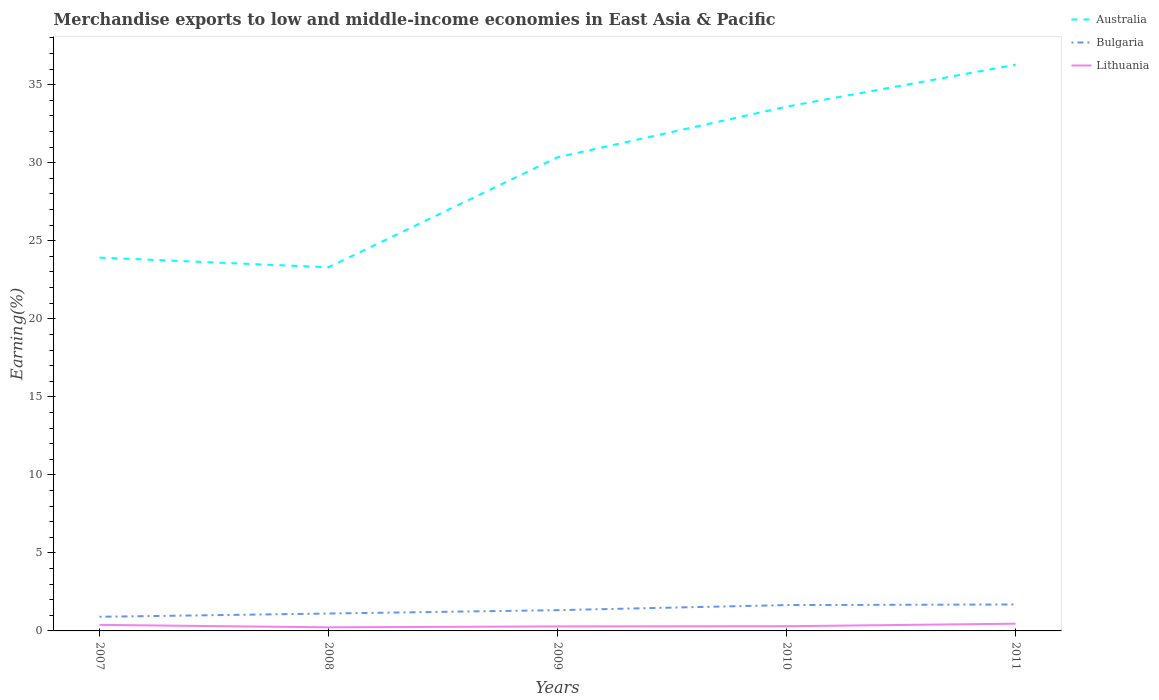Across all years, what is the maximum percentage of amount earned from merchandise exports in Australia?
Give a very brief answer. 23.3. What is the total percentage of amount earned from merchandise exports in Lithuania in the graph?
Your answer should be compact. -0.23. What is the difference between the highest and the second highest percentage of amount earned from merchandise exports in Bulgaria?
Keep it short and to the point. 0.79. How many lines are there?
Offer a very short reply. 3. What is the difference between two consecutive major ticks on the Y-axis?
Keep it short and to the point. 5. Are the values on the major ticks of Y-axis written in scientific E-notation?
Keep it short and to the point. No. Where does the legend appear in the graph?
Your answer should be very brief. Top right. How many legend labels are there?
Your answer should be very brief. 3. How are the legend labels stacked?
Your answer should be compact. Vertical. What is the title of the graph?
Your response must be concise. Merchandise exports to low and middle-income economies in East Asia & Pacific. What is the label or title of the X-axis?
Your response must be concise. Years. What is the label or title of the Y-axis?
Provide a short and direct response. Earning(%). What is the Earning(%) in Australia in 2007?
Offer a very short reply. 23.92. What is the Earning(%) of Bulgaria in 2007?
Your response must be concise. 0.91. What is the Earning(%) in Lithuania in 2007?
Give a very brief answer. 0.39. What is the Earning(%) of Australia in 2008?
Offer a terse response. 23.3. What is the Earning(%) of Bulgaria in 2008?
Your answer should be compact. 1.11. What is the Earning(%) of Lithuania in 2008?
Your answer should be compact. 0.23. What is the Earning(%) of Australia in 2009?
Your response must be concise. 30.35. What is the Earning(%) of Bulgaria in 2009?
Provide a short and direct response. 1.33. What is the Earning(%) in Lithuania in 2009?
Your answer should be very brief. 0.29. What is the Earning(%) in Australia in 2010?
Ensure brevity in your answer.  33.6. What is the Earning(%) of Bulgaria in 2010?
Make the answer very short. 1.66. What is the Earning(%) of Lithuania in 2010?
Provide a short and direct response. 0.3. What is the Earning(%) in Australia in 2011?
Your answer should be compact. 36.28. What is the Earning(%) in Bulgaria in 2011?
Your answer should be very brief. 1.69. What is the Earning(%) of Lithuania in 2011?
Give a very brief answer. 0.46. Across all years, what is the maximum Earning(%) in Australia?
Offer a terse response. 36.28. Across all years, what is the maximum Earning(%) of Bulgaria?
Make the answer very short. 1.69. Across all years, what is the maximum Earning(%) in Lithuania?
Your answer should be very brief. 0.46. Across all years, what is the minimum Earning(%) in Australia?
Provide a succinct answer. 23.3. Across all years, what is the minimum Earning(%) in Bulgaria?
Provide a succinct answer. 0.91. Across all years, what is the minimum Earning(%) in Lithuania?
Make the answer very short. 0.23. What is the total Earning(%) of Australia in the graph?
Your answer should be compact. 147.46. What is the total Earning(%) in Bulgaria in the graph?
Offer a very short reply. 6.7. What is the total Earning(%) in Lithuania in the graph?
Provide a short and direct response. 1.67. What is the difference between the Earning(%) in Australia in 2007 and that in 2008?
Your response must be concise. 0.62. What is the difference between the Earning(%) in Bulgaria in 2007 and that in 2008?
Give a very brief answer. -0.21. What is the difference between the Earning(%) in Lithuania in 2007 and that in 2008?
Keep it short and to the point. 0.16. What is the difference between the Earning(%) in Australia in 2007 and that in 2009?
Provide a succinct answer. -6.43. What is the difference between the Earning(%) in Bulgaria in 2007 and that in 2009?
Give a very brief answer. -0.42. What is the difference between the Earning(%) in Lithuania in 2007 and that in 2009?
Your answer should be compact. 0.1. What is the difference between the Earning(%) of Australia in 2007 and that in 2010?
Your answer should be compact. -9.68. What is the difference between the Earning(%) in Bulgaria in 2007 and that in 2010?
Offer a very short reply. -0.75. What is the difference between the Earning(%) in Lithuania in 2007 and that in 2010?
Give a very brief answer. 0.09. What is the difference between the Earning(%) in Australia in 2007 and that in 2011?
Offer a terse response. -12.36. What is the difference between the Earning(%) in Bulgaria in 2007 and that in 2011?
Your answer should be very brief. -0.79. What is the difference between the Earning(%) of Lithuania in 2007 and that in 2011?
Provide a succinct answer. -0.08. What is the difference between the Earning(%) of Australia in 2008 and that in 2009?
Ensure brevity in your answer.  -7.05. What is the difference between the Earning(%) in Bulgaria in 2008 and that in 2009?
Your answer should be very brief. -0.22. What is the difference between the Earning(%) of Lithuania in 2008 and that in 2009?
Your response must be concise. -0.06. What is the difference between the Earning(%) in Australia in 2008 and that in 2010?
Make the answer very short. -10.29. What is the difference between the Earning(%) in Bulgaria in 2008 and that in 2010?
Your response must be concise. -0.54. What is the difference between the Earning(%) in Lithuania in 2008 and that in 2010?
Your answer should be compact. -0.07. What is the difference between the Earning(%) of Australia in 2008 and that in 2011?
Provide a short and direct response. -12.98. What is the difference between the Earning(%) in Bulgaria in 2008 and that in 2011?
Provide a short and direct response. -0.58. What is the difference between the Earning(%) of Lithuania in 2008 and that in 2011?
Your answer should be compact. -0.23. What is the difference between the Earning(%) in Australia in 2009 and that in 2010?
Your answer should be very brief. -3.25. What is the difference between the Earning(%) of Bulgaria in 2009 and that in 2010?
Ensure brevity in your answer.  -0.33. What is the difference between the Earning(%) in Lithuania in 2009 and that in 2010?
Your answer should be compact. -0.01. What is the difference between the Earning(%) in Australia in 2009 and that in 2011?
Keep it short and to the point. -5.93. What is the difference between the Earning(%) in Bulgaria in 2009 and that in 2011?
Ensure brevity in your answer.  -0.36. What is the difference between the Earning(%) of Lithuania in 2009 and that in 2011?
Your answer should be compact. -0.17. What is the difference between the Earning(%) of Australia in 2010 and that in 2011?
Keep it short and to the point. -2.69. What is the difference between the Earning(%) in Bulgaria in 2010 and that in 2011?
Offer a terse response. -0.04. What is the difference between the Earning(%) of Lithuania in 2010 and that in 2011?
Your answer should be compact. -0.16. What is the difference between the Earning(%) in Australia in 2007 and the Earning(%) in Bulgaria in 2008?
Offer a very short reply. 22.81. What is the difference between the Earning(%) in Australia in 2007 and the Earning(%) in Lithuania in 2008?
Provide a short and direct response. 23.69. What is the difference between the Earning(%) of Bulgaria in 2007 and the Earning(%) of Lithuania in 2008?
Keep it short and to the point. 0.67. What is the difference between the Earning(%) of Australia in 2007 and the Earning(%) of Bulgaria in 2009?
Make the answer very short. 22.59. What is the difference between the Earning(%) in Australia in 2007 and the Earning(%) in Lithuania in 2009?
Your answer should be compact. 23.63. What is the difference between the Earning(%) of Bulgaria in 2007 and the Earning(%) of Lithuania in 2009?
Ensure brevity in your answer.  0.62. What is the difference between the Earning(%) in Australia in 2007 and the Earning(%) in Bulgaria in 2010?
Provide a short and direct response. 22.26. What is the difference between the Earning(%) in Australia in 2007 and the Earning(%) in Lithuania in 2010?
Your response must be concise. 23.62. What is the difference between the Earning(%) in Bulgaria in 2007 and the Earning(%) in Lithuania in 2010?
Provide a succinct answer. 0.6. What is the difference between the Earning(%) in Australia in 2007 and the Earning(%) in Bulgaria in 2011?
Provide a succinct answer. 22.23. What is the difference between the Earning(%) of Australia in 2007 and the Earning(%) of Lithuania in 2011?
Make the answer very short. 23.46. What is the difference between the Earning(%) of Bulgaria in 2007 and the Earning(%) of Lithuania in 2011?
Offer a terse response. 0.44. What is the difference between the Earning(%) in Australia in 2008 and the Earning(%) in Bulgaria in 2009?
Your response must be concise. 21.97. What is the difference between the Earning(%) in Australia in 2008 and the Earning(%) in Lithuania in 2009?
Keep it short and to the point. 23.01. What is the difference between the Earning(%) of Bulgaria in 2008 and the Earning(%) of Lithuania in 2009?
Offer a terse response. 0.83. What is the difference between the Earning(%) of Australia in 2008 and the Earning(%) of Bulgaria in 2010?
Your response must be concise. 21.65. What is the difference between the Earning(%) in Australia in 2008 and the Earning(%) in Lithuania in 2010?
Give a very brief answer. 23. What is the difference between the Earning(%) of Bulgaria in 2008 and the Earning(%) of Lithuania in 2010?
Make the answer very short. 0.81. What is the difference between the Earning(%) of Australia in 2008 and the Earning(%) of Bulgaria in 2011?
Make the answer very short. 21.61. What is the difference between the Earning(%) of Australia in 2008 and the Earning(%) of Lithuania in 2011?
Offer a terse response. 22.84. What is the difference between the Earning(%) of Bulgaria in 2008 and the Earning(%) of Lithuania in 2011?
Keep it short and to the point. 0.65. What is the difference between the Earning(%) of Australia in 2009 and the Earning(%) of Bulgaria in 2010?
Your answer should be very brief. 28.69. What is the difference between the Earning(%) of Australia in 2009 and the Earning(%) of Lithuania in 2010?
Give a very brief answer. 30.05. What is the difference between the Earning(%) in Bulgaria in 2009 and the Earning(%) in Lithuania in 2010?
Offer a very short reply. 1.03. What is the difference between the Earning(%) in Australia in 2009 and the Earning(%) in Bulgaria in 2011?
Provide a short and direct response. 28.66. What is the difference between the Earning(%) in Australia in 2009 and the Earning(%) in Lithuania in 2011?
Provide a succinct answer. 29.89. What is the difference between the Earning(%) in Bulgaria in 2009 and the Earning(%) in Lithuania in 2011?
Keep it short and to the point. 0.87. What is the difference between the Earning(%) in Australia in 2010 and the Earning(%) in Bulgaria in 2011?
Offer a very short reply. 31.9. What is the difference between the Earning(%) in Australia in 2010 and the Earning(%) in Lithuania in 2011?
Give a very brief answer. 33.13. What is the difference between the Earning(%) of Bulgaria in 2010 and the Earning(%) of Lithuania in 2011?
Your answer should be compact. 1.19. What is the average Earning(%) in Australia per year?
Keep it short and to the point. 29.49. What is the average Earning(%) of Bulgaria per year?
Offer a terse response. 1.34. What is the average Earning(%) of Lithuania per year?
Your answer should be very brief. 0.33. In the year 2007, what is the difference between the Earning(%) of Australia and Earning(%) of Bulgaria?
Ensure brevity in your answer.  23.02. In the year 2007, what is the difference between the Earning(%) of Australia and Earning(%) of Lithuania?
Provide a succinct answer. 23.53. In the year 2007, what is the difference between the Earning(%) in Bulgaria and Earning(%) in Lithuania?
Offer a very short reply. 0.52. In the year 2008, what is the difference between the Earning(%) of Australia and Earning(%) of Bulgaria?
Provide a succinct answer. 22.19. In the year 2008, what is the difference between the Earning(%) in Australia and Earning(%) in Lithuania?
Provide a succinct answer. 23.07. In the year 2008, what is the difference between the Earning(%) of Bulgaria and Earning(%) of Lithuania?
Offer a terse response. 0.88. In the year 2009, what is the difference between the Earning(%) of Australia and Earning(%) of Bulgaria?
Make the answer very short. 29.02. In the year 2009, what is the difference between the Earning(%) in Australia and Earning(%) in Lithuania?
Provide a short and direct response. 30.06. In the year 2009, what is the difference between the Earning(%) in Bulgaria and Earning(%) in Lithuania?
Offer a terse response. 1.04. In the year 2010, what is the difference between the Earning(%) in Australia and Earning(%) in Bulgaria?
Provide a succinct answer. 31.94. In the year 2010, what is the difference between the Earning(%) of Australia and Earning(%) of Lithuania?
Your answer should be very brief. 33.3. In the year 2010, what is the difference between the Earning(%) of Bulgaria and Earning(%) of Lithuania?
Your answer should be compact. 1.36. In the year 2011, what is the difference between the Earning(%) in Australia and Earning(%) in Bulgaria?
Your answer should be compact. 34.59. In the year 2011, what is the difference between the Earning(%) in Australia and Earning(%) in Lithuania?
Give a very brief answer. 35.82. In the year 2011, what is the difference between the Earning(%) in Bulgaria and Earning(%) in Lithuania?
Offer a very short reply. 1.23. What is the ratio of the Earning(%) in Australia in 2007 to that in 2008?
Offer a terse response. 1.03. What is the ratio of the Earning(%) in Bulgaria in 2007 to that in 2008?
Keep it short and to the point. 0.81. What is the ratio of the Earning(%) of Lithuania in 2007 to that in 2008?
Your response must be concise. 1.68. What is the ratio of the Earning(%) in Australia in 2007 to that in 2009?
Offer a very short reply. 0.79. What is the ratio of the Earning(%) of Bulgaria in 2007 to that in 2009?
Give a very brief answer. 0.68. What is the ratio of the Earning(%) in Lithuania in 2007 to that in 2009?
Your response must be concise. 1.34. What is the ratio of the Earning(%) in Australia in 2007 to that in 2010?
Give a very brief answer. 0.71. What is the ratio of the Earning(%) of Bulgaria in 2007 to that in 2010?
Give a very brief answer. 0.55. What is the ratio of the Earning(%) of Lithuania in 2007 to that in 2010?
Offer a very short reply. 1.28. What is the ratio of the Earning(%) of Australia in 2007 to that in 2011?
Your response must be concise. 0.66. What is the ratio of the Earning(%) of Bulgaria in 2007 to that in 2011?
Your answer should be very brief. 0.53. What is the ratio of the Earning(%) of Lithuania in 2007 to that in 2011?
Your response must be concise. 0.84. What is the ratio of the Earning(%) of Australia in 2008 to that in 2009?
Provide a succinct answer. 0.77. What is the ratio of the Earning(%) of Bulgaria in 2008 to that in 2009?
Make the answer very short. 0.84. What is the ratio of the Earning(%) of Lithuania in 2008 to that in 2009?
Provide a short and direct response. 0.8. What is the ratio of the Earning(%) in Australia in 2008 to that in 2010?
Ensure brevity in your answer.  0.69. What is the ratio of the Earning(%) of Bulgaria in 2008 to that in 2010?
Your answer should be compact. 0.67. What is the ratio of the Earning(%) of Lithuania in 2008 to that in 2010?
Your response must be concise. 0.77. What is the ratio of the Earning(%) in Australia in 2008 to that in 2011?
Give a very brief answer. 0.64. What is the ratio of the Earning(%) in Bulgaria in 2008 to that in 2011?
Give a very brief answer. 0.66. What is the ratio of the Earning(%) in Lithuania in 2008 to that in 2011?
Provide a short and direct response. 0.5. What is the ratio of the Earning(%) of Australia in 2009 to that in 2010?
Keep it short and to the point. 0.9. What is the ratio of the Earning(%) of Bulgaria in 2009 to that in 2010?
Give a very brief answer. 0.8. What is the ratio of the Earning(%) of Australia in 2009 to that in 2011?
Your response must be concise. 0.84. What is the ratio of the Earning(%) in Bulgaria in 2009 to that in 2011?
Your response must be concise. 0.79. What is the ratio of the Earning(%) of Lithuania in 2009 to that in 2011?
Provide a short and direct response. 0.63. What is the ratio of the Earning(%) in Australia in 2010 to that in 2011?
Your response must be concise. 0.93. What is the ratio of the Earning(%) in Bulgaria in 2010 to that in 2011?
Provide a short and direct response. 0.98. What is the ratio of the Earning(%) of Lithuania in 2010 to that in 2011?
Ensure brevity in your answer.  0.65. What is the difference between the highest and the second highest Earning(%) in Australia?
Provide a succinct answer. 2.69. What is the difference between the highest and the second highest Earning(%) of Bulgaria?
Make the answer very short. 0.04. What is the difference between the highest and the second highest Earning(%) of Lithuania?
Your response must be concise. 0.08. What is the difference between the highest and the lowest Earning(%) of Australia?
Your response must be concise. 12.98. What is the difference between the highest and the lowest Earning(%) in Bulgaria?
Provide a short and direct response. 0.79. What is the difference between the highest and the lowest Earning(%) in Lithuania?
Provide a succinct answer. 0.23. 